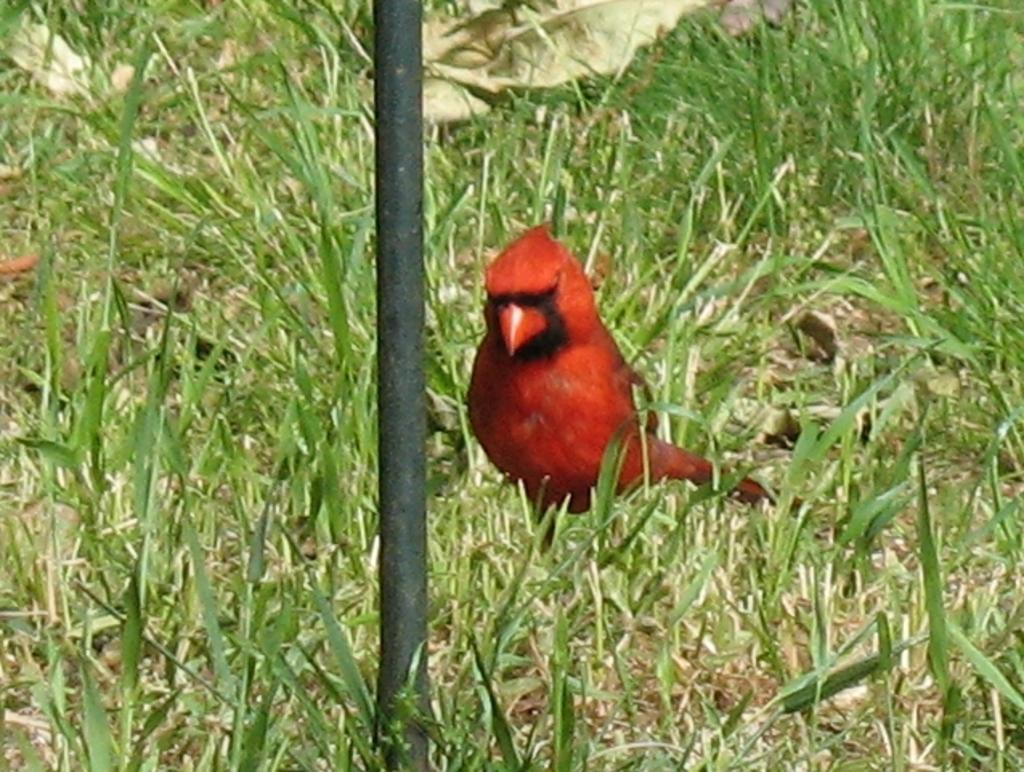What type of bird can be seen in the image? There is a red color bird in the image. Where is the bird located? The bird is on the grass. What other object can be seen in the image? There is a pole in the image. What type of mask is the bird wearing in the image? There is no mask present on the bird in the image. What border is visible around the image? The image does not show any borders; it is a photograph or illustration of a scene. 